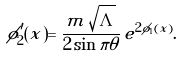Convert formula to latex. <formula><loc_0><loc_0><loc_500><loc_500>\phi _ { 2 } ^ { \prime } ( x ) = \frac { m \, \sqrt { \Lambda } } { 2 \sin \pi \theta } \, e ^ { 2 \phi _ { 1 } ( x ) } .</formula> 